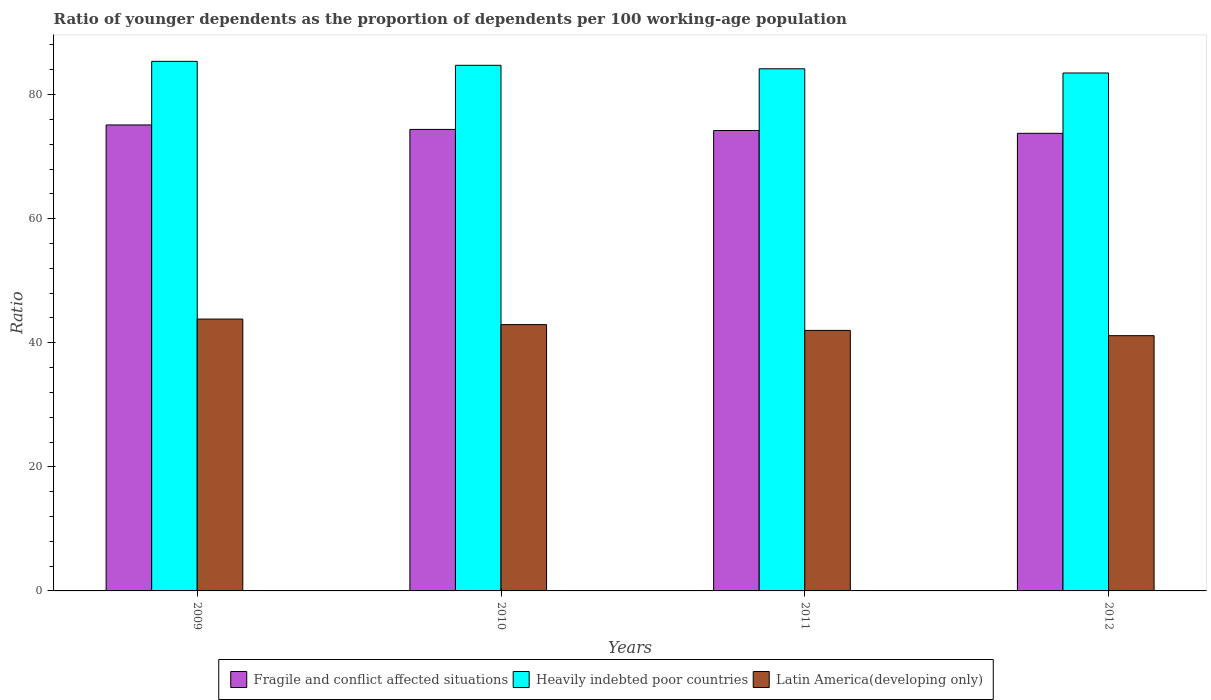How many different coloured bars are there?
Your answer should be very brief. 3. What is the age dependency ratio(young) in Latin America(developing only) in 2010?
Your answer should be very brief. 42.92. Across all years, what is the maximum age dependency ratio(young) in Heavily indebted poor countries?
Keep it short and to the point. 85.36. Across all years, what is the minimum age dependency ratio(young) in Latin America(developing only)?
Make the answer very short. 41.14. In which year was the age dependency ratio(young) in Heavily indebted poor countries maximum?
Your answer should be compact. 2009. What is the total age dependency ratio(young) in Fragile and conflict affected situations in the graph?
Ensure brevity in your answer.  297.46. What is the difference between the age dependency ratio(young) in Heavily indebted poor countries in 2009 and that in 2012?
Provide a short and direct response. 1.88. What is the difference between the age dependency ratio(young) in Fragile and conflict affected situations in 2009 and the age dependency ratio(young) in Latin America(developing only) in 2012?
Give a very brief answer. 33.96. What is the average age dependency ratio(young) in Fragile and conflict affected situations per year?
Ensure brevity in your answer.  74.36. In the year 2009, what is the difference between the age dependency ratio(young) in Fragile and conflict affected situations and age dependency ratio(young) in Latin America(developing only)?
Give a very brief answer. 31.29. In how many years, is the age dependency ratio(young) in Fragile and conflict affected situations greater than 64?
Make the answer very short. 4. What is the ratio of the age dependency ratio(young) in Heavily indebted poor countries in 2010 to that in 2011?
Give a very brief answer. 1.01. Is the age dependency ratio(young) in Fragile and conflict affected situations in 2009 less than that in 2012?
Keep it short and to the point. No. Is the difference between the age dependency ratio(young) in Fragile and conflict affected situations in 2009 and 2010 greater than the difference between the age dependency ratio(young) in Latin America(developing only) in 2009 and 2010?
Give a very brief answer. No. What is the difference between the highest and the second highest age dependency ratio(young) in Fragile and conflict affected situations?
Provide a short and direct response. 0.72. What is the difference between the highest and the lowest age dependency ratio(young) in Heavily indebted poor countries?
Provide a short and direct response. 1.88. Is the sum of the age dependency ratio(young) in Latin America(developing only) in 2010 and 2012 greater than the maximum age dependency ratio(young) in Fragile and conflict affected situations across all years?
Provide a succinct answer. Yes. What does the 3rd bar from the left in 2011 represents?
Your answer should be compact. Latin America(developing only). What does the 2nd bar from the right in 2012 represents?
Your answer should be very brief. Heavily indebted poor countries. Is it the case that in every year, the sum of the age dependency ratio(young) in Fragile and conflict affected situations and age dependency ratio(young) in Heavily indebted poor countries is greater than the age dependency ratio(young) in Latin America(developing only)?
Give a very brief answer. Yes. What is the difference between two consecutive major ticks on the Y-axis?
Offer a very short reply. 20. Are the values on the major ticks of Y-axis written in scientific E-notation?
Your answer should be very brief. No. Does the graph contain any zero values?
Ensure brevity in your answer.  No. Does the graph contain grids?
Your answer should be very brief. No. Where does the legend appear in the graph?
Make the answer very short. Bottom center. What is the title of the graph?
Give a very brief answer. Ratio of younger dependents as the proportion of dependents per 100 working-age population. Does "Venezuela" appear as one of the legend labels in the graph?
Provide a succinct answer. No. What is the label or title of the Y-axis?
Provide a succinct answer. Ratio. What is the Ratio of Fragile and conflict affected situations in 2009?
Your answer should be very brief. 75.11. What is the Ratio of Heavily indebted poor countries in 2009?
Provide a short and direct response. 85.36. What is the Ratio of Latin America(developing only) in 2009?
Your answer should be compact. 43.82. What is the Ratio of Fragile and conflict affected situations in 2010?
Provide a succinct answer. 74.39. What is the Ratio of Heavily indebted poor countries in 2010?
Your response must be concise. 84.72. What is the Ratio in Latin America(developing only) in 2010?
Provide a succinct answer. 42.92. What is the Ratio in Fragile and conflict affected situations in 2011?
Your answer should be compact. 74.21. What is the Ratio of Heavily indebted poor countries in 2011?
Offer a very short reply. 84.16. What is the Ratio in Latin America(developing only) in 2011?
Provide a short and direct response. 41.99. What is the Ratio of Fragile and conflict affected situations in 2012?
Provide a short and direct response. 73.76. What is the Ratio in Heavily indebted poor countries in 2012?
Provide a short and direct response. 83.48. What is the Ratio of Latin America(developing only) in 2012?
Make the answer very short. 41.14. Across all years, what is the maximum Ratio of Fragile and conflict affected situations?
Offer a very short reply. 75.11. Across all years, what is the maximum Ratio in Heavily indebted poor countries?
Offer a terse response. 85.36. Across all years, what is the maximum Ratio in Latin America(developing only)?
Give a very brief answer. 43.82. Across all years, what is the minimum Ratio of Fragile and conflict affected situations?
Your answer should be very brief. 73.76. Across all years, what is the minimum Ratio of Heavily indebted poor countries?
Your answer should be very brief. 83.48. Across all years, what is the minimum Ratio in Latin America(developing only)?
Provide a short and direct response. 41.14. What is the total Ratio of Fragile and conflict affected situations in the graph?
Offer a terse response. 297.46. What is the total Ratio in Heavily indebted poor countries in the graph?
Provide a short and direct response. 337.71. What is the total Ratio of Latin America(developing only) in the graph?
Ensure brevity in your answer.  169.87. What is the difference between the Ratio of Fragile and conflict affected situations in 2009 and that in 2010?
Your answer should be very brief. 0.72. What is the difference between the Ratio in Heavily indebted poor countries in 2009 and that in 2010?
Offer a terse response. 0.64. What is the difference between the Ratio of Latin America(developing only) in 2009 and that in 2010?
Give a very brief answer. 0.89. What is the difference between the Ratio in Fragile and conflict affected situations in 2009 and that in 2011?
Your answer should be very brief. 0.9. What is the difference between the Ratio of Heavily indebted poor countries in 2009 and that in 2011?
Your response must be concise. 1.2. What is the difference between the Ratio in Latin America(developing only) in 2009 and that in 2011?
Your response must be concise. 1.83. What is the difference between the Ratio of Fragile and conflict affected situations in 2009 and that in 2012?
Ensure brevity in your answer.  1.35. What is the difference between the Ratio in Heavily indebted poor countries in 2009 and that in 2012?
Keep it short and to the point. 1.88. What is the difference between the Ratio of Latin America(developing only) in 2009 and that in 2012?
Provide a short and direct response. 2.67. What is the difference between the Ratio of Fragile and conflict affected situations in 2010 and that in 2011?
Your response must be concise. 0.18. What is the difference between the Ratio of Heavily indebted poor countries in 2010 and that in 2011?
Provide a succinct answer. 0.56. What is the difference between the Ratio of Latin America(developing only) in 2010 and that in 2011?
Provide a short and direct response. 0.93. What is the difference between the Ratio of Fragile and conflict affected situations in 2010 and that in 2012?
Your response must be concise. 0.63. What is the difference between the Ratio in Heavily indebted poor countries in 2010 and that in 2012?
Provide a short and direct response. 1.24. What is the difference between the Ratio of Latin America(developing only) in 2010 and that in 2012?
Your response must be concise. 1.78. What is the difference between the Ratio in Fragile and conflict affected situations in 2011 and that in 2012?
Your answer should be very brief. 0.45. What is the difference between the Ratio of Heavily indebted poor countries in 2011 and that in 2012?
Give a very brief answer. 0.68. What is the difference between the Ratio of Latin America(developing only) in 2011 and that in 2012?
Offer a terse response. 0.85. What is the difference between the Ratio of Fragile and conflict affected situations in 2009 and the Ratio of Heavily indebted poor countries in 2010?
Ensure brevity in your answer.  -9.61. What is the difference between the Ratio of Fragile and conflict affected situations in 2009 and the Ratio of Latin America(developing only) in 2010?
Provide a short and direct response. 32.18. What is the difference between the Ratio in Heavily indebted poor countries in 2009 and the Ratio in Latin America(developing only) in 2010?
Your answer should be very brief. 42.43. What is the difference between the Ratio of Fragile and conflict affected situations in 2009 and the Ratio of Heavily indebted poor countries in 2011?
Your response must be concise. -9.05. What is the difference between the Ratio in Fragile and conflict affected situations in 2009 and the Ratio in Latin America(developing only) in 2011?
Make the answer very short. 33.12. What is the difference between the Ratio in Heavily indebted poor countries in 2009 and the Ratio in Latin America(developing only) in 2011?
Make the answer very short. 43.37. What is the difference between the Ratio in Fragile and conflict affected situations in 2009 and the Ratio in Heavily indebted poor countries in 2012?
Keep it short and to the point. -8.37. What is the difference between the Ratio of Fragile and conflict affected situations in 2009 and the Ratio of Latin America(developing only) in 2012?
Your answer should be very brief. 33.96. What is the difference between the Ratio of Heavily indebted poor countries in 2009 and the Ratio of Latin America(developing only) in 2012?
Your response must be concise. 44.21. What is the difference between the Ratio in Fragile and conflict affected situations in 2010 and the Ratio in Heavily indebted poor countries in 2011?
Keep it short and to the point. -9.77. What is the difference between the Ratio in Fragile and conflict affected situations in 2010 and the Ratio in Latin America(developing only) in 2011?
Your response must be concise. 32.4. What is the difference between the Ratio in Heavily indebted poor countries in 2010 and the Ratio in Latin America(developing only) in 2011?
Your answer should be very brief. 42.73. What is the difference between the Ratio of Fragile and conflict affected situations in 2010 and the Ratio of Heavily indebted poor countries in 2012?
Your answer should be compact. -9.09. What is the difference between the Ratio in Fragile and conflict affected situations in 2010 and the Ratio in Latin America(developing only) in 2012?
Ensure brevity in your answer.  33.24. What is the difference between the Ratio of Heavily indebted poor countries in 2010 and the Ratio of Latin America(developing only) in 2012?
Your answer should be compact. 43.58. What is the difference between the Ratio of Fragile and conflict affected situations in 2011 and the Ratio of Heavily indebted poor countries in 2012?
Give a very brief answer. -9.27. What is the difference between the Ratio of Fragile and conflict affected situations in 2011 and the Ratio of Latin America(developing only) in 2012?
Make the answer very short. 33.07. What is the difference between the Ratio of Heavily indebted poor countries in 2011 and the Ratio of Latin America(developing only) in 2012?
Ensure brevity in your answer.  43.02. What is the average Ratio in Fragile and conflict affected situations per year?
Your response must be concise. 74.36. What is the average Ratio of Heavily indebted poor countries per year?
Your answer should be very brief. 84.43. What is the average Ratio of Latin America(developing only) per year?
Your answer should be very brief. 42.47. In the year 2009, what is the difference between the Ratio in Fragile and conflict affected situations and Ratio in Heavily indebted poor countries?
Offer a terse response. -10.25. In the year 2009, what is the difference between the Ratio in Fragile and conflict affected situations and Ratio in Latin America(developing only)?
Give a very brief answer. 31.29. In the year 2009, what is the difference between the Ratio of Heavily indebted poor countries and Ratio of Latin America(developing only)?
Provide a short and direct response. 41.54. In the year 2010, what is the difference between the Ratio of Fragile and conflict affected situations and Ratio of Heavily indebted poor countries?
Make the answer very short. -10.33. In the year 2010, what is the difference between the Ratio in Fragile and conflict affected situations and Ratio in Latin America(developing only)?
Offer a terse response. 31.46. In the year 2010, what is the difference between the Ratio of Heavily indebted poor countries and Ratio of Latin America(developing only)?
Ensure brevity in your answer.  41.8. In the year 2011, what is the difference between the Ratio of Fragile and conflict affected situations and Ratio of Heavily indebted poor countries?
Offer a terse response. -9.95. In the year 2011, what is the difference between the Ratio in Fragile and conflict affected situations and Ratio in Latin America(developing only)?
Offer a terse response. 32.22. In the year 2011, what is the difference between the Ratio of Heavily indebted poor countries and Ratio of Latin America(developing only)?
Provide a succinct answer. 42.17. In the year 2012, what is the difference between the Ratio in Fragile and conflict affected situations and Ratio in Heavily indebted poor countries?
Provide a short and direct response. -9.72. In the year 2012, what is the difference between the Ratio of Fragile and conflict affected situations and Ratio of Latin America(developing only)?
Give a very brief answer. 32.62. In the year 2012, what is the difference between the Ratio in Heavily indebted poor countries and Ratio in Latin America(developing only)?
Offer a terse response. 42.34. What is the ratio of the Ratio of Fragile and conflict affected situations in 2009 to that in 2010?
Give a very brief answer. 1.01. What is the ratio of the Ratio of Heavily indebted poor countries in 2009 to that in 2010?
Give a very brief answer. 1.01. What is the ratio of the Ratio in Latin America(developing only) in 2009 to that in 2010?
Your answer should be compact. 1.02. What is the ratio of the Ratio of Fragile and conflict affected situations in 2009 to that in 2011?
Offer a very short reply. 1.01. What is the ratio of the Ratio of Heavily indebted poor countries in 2009 to that in 2011?
Your answer should be very brief. 1.01. What is the ratio of the Ratio of Latin America(developing only) in 2009 to that in 2011?
Give a very brief answer. 1.04. What is the ratio of the Ratio of Fragile and conflict affected situations in 2009 to that in 2012?
Offer a terse response. 1.02. What is the ratio of the Ratio of Heavily indebted poor countries in 2009 to that in 2012?
Make the answer very short. 1.02. What is the ratio of the Ratio of Latin America(developing only) in 2009 to that in 2012?
Your answer should be compact. 1.06. What is the ratio of the Ratio in Heavily indebted poor countries in 2010 to that in 2011?
Your answer should be compact. 1.01. What is the ratio of the Ratio in Latin America(developing only) in 2010 to that in 2011?
Offer a very short reply. 1.02. What is the ratio of the Ratio of Fragile and conflict affected situations in 2010 to that in 2012?
Offer a terse response. 1.01. What is the ratio of the Ratio in Heavily indebted poor countries in 2010 to that in 2012?
Provide a succinct answer. 1.01. What is the ratio of the Ratio in Latin America(developing only) in 2010 to that in 2012?
Provide a short and direct response. 1.04. What is the ratio of the Ratio in Fragile and conflict affected situations in 2011 to that in 2012?
Your response must be concise. 1.01. What is the ratio of the Ratio in Latin America(developing only) in 2011 to that in 2012?
Provide a short and direct response. 1.02. What is the difference between the highest and the second highest Ratio of Fragile and conflict affected situations?
Make the answer very short. 0.72. What is the difference between the highest and the second highest Ratio in Heavily indebted poor countries?
Your answer should be very brief. 0.64. What is the difference between the highest and the second highest Ratio in Latin America(developing only)?
Your answer should be very brief. 0.89. What is the difference between the highest and the lowest Ratio in Fragile and conflict affected situations?
Offer a very short reply. 1.35. What is the difference between the highest and the lowest Ratio of Heavily indebted poor countries?
Your answer should be compact. 1.88. What is the difference between the highest and the lowest Ratio of Latin America(developing only)?
Offer a terse response. 2.67. 